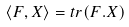Convert formula to latex. <formula><loc_0><loc_0><loc_500><loc_500>\langle F , X \rangle = t r ( F . X )</formula> 